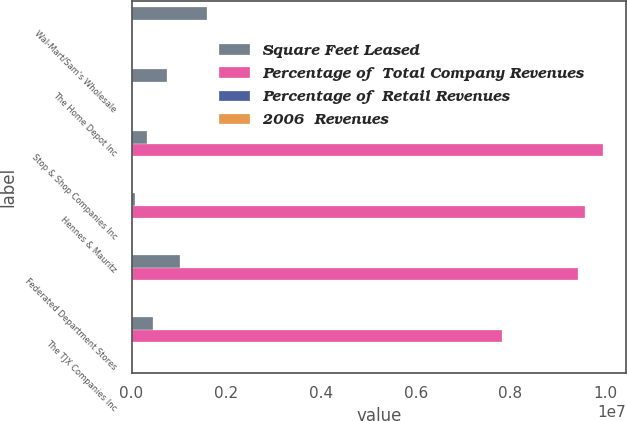Convert chart. <chart><loc_0><loc_0><loc_500><loc_500><stacked_bar_chart><ecel><fcel>Wal-Mart/Sam's Wholesale<fcel>The Home Depot Inc<fcel>Stop & Shop Companies Inc<fcel>Hennes & Mauritz<fcel>Federated Department Stores<fcel>The TJX Companies Inc<nl><fcel>Square Feet Leased<fcel>1.599e+06<fcel>758000<fcel>320000<fcel>83000<fcel>1.031e+06<fcel>455000<nl><fcel>Percentage of  Total Company Revenues<fcel>3.45<fcel>3.45<fcel>9.948e+06<fcel>9.583e+06<fcel>9.43e+06<fcel>7.824e+06<nl><fcel>Percentage of  Retail Revenues<fcel>3.7<fcel>3.2<fcel>2.5<fcel>2.4<fcel>2.4<fcel>2<nl><fcel>2006  Revenues<fcel>0.5<fcel>0.5<fcel>0.4<fcel>0.4<fcel>0.3<fcel>0.3<nl></chart> 